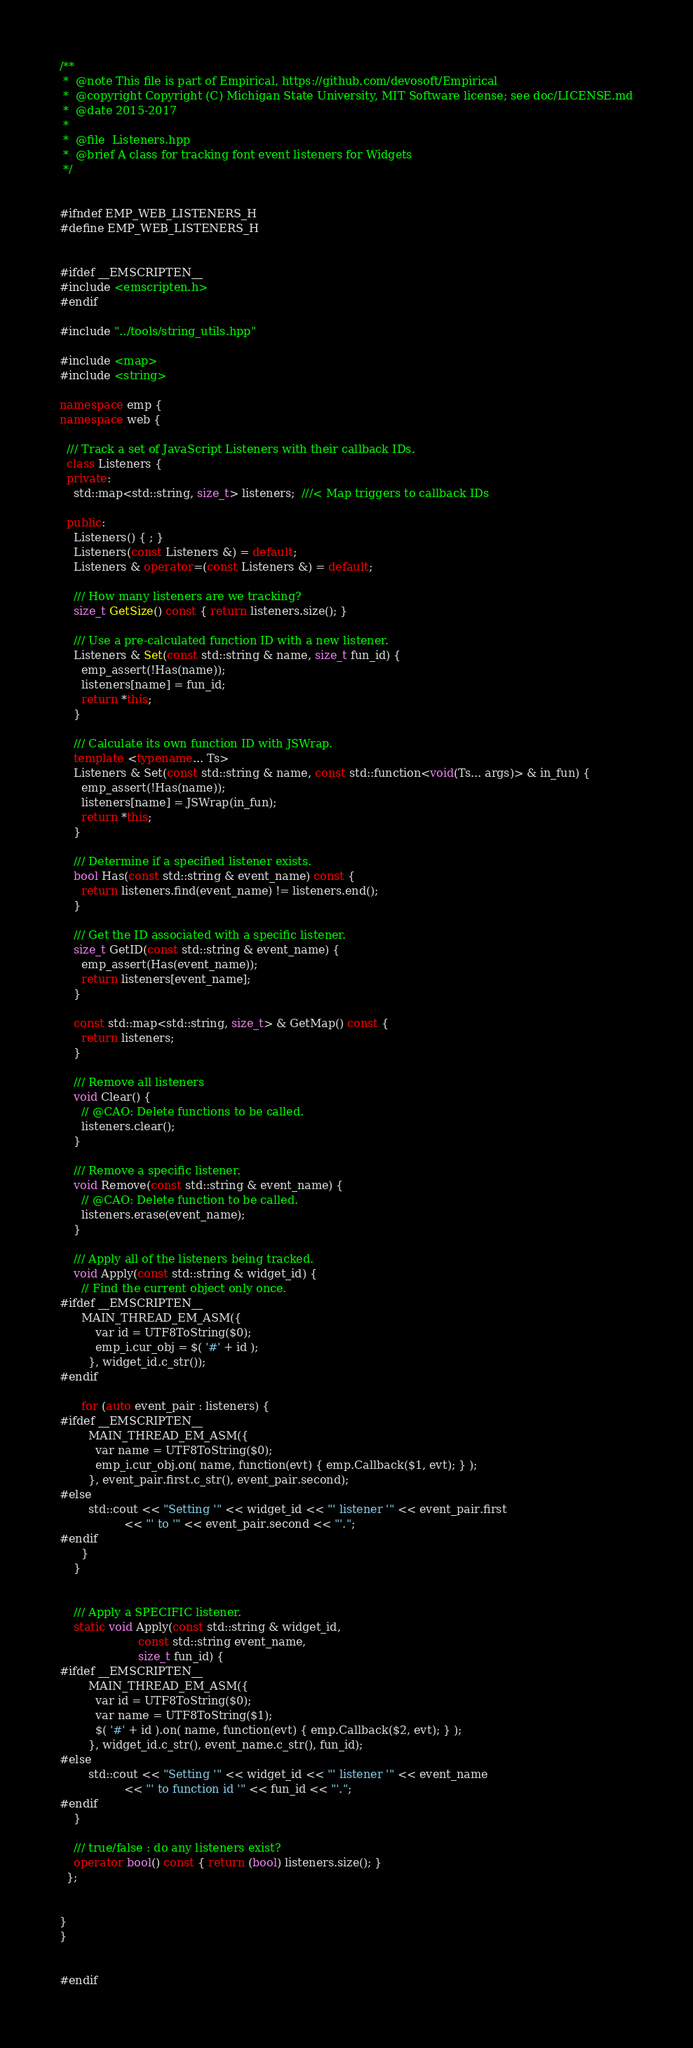Convert code to text. <code><loc_0><loc_0><loc_500><loc_500><_C++_>/**
 *  @note This file is part of Empirical, https://github.com/devosoft/Empirical
 *  @copyright Copyright (C) Michigan State University, MIT Software license; see doc/LICENSE.md
 *  @date 2015-2017
 *
 *  @file  Listeners.hpp
 *  @brief A class for tracking font event listeners for Widgets
 */


#ifndef EMP_WEB_LISTENERS_H
#define EMP_WEB_LISTENERS_H


#ifdef __EMSCRIPTEN__
#include <emscripten.h>
#endif

#include "../tools/string_utils.hpp"

#include <map>
#include <string>

namespace emp {
namespace web {

  /// Track a set of JavaScript Listeners with their callback IDs.
  class Listeners {
  private:
    std::map<std::string, size_t> listeners;  ///< Map triggers to callback IDs

  public:
    Listeners() { ; }
    Listeners(const Listeners &) = default;
    Listeners & operator=(const Listeners &) = default;

    /// How many listeners are we tracking?
    size_t GetSize() const { return listeners.size(); }

    /// Use a pre-calculated function ID with a new listener.
    Listeners & Set(const std::string & name, size_t fun_id) {
      emp_assert(!Has(name));
      listeners[name] = fun_id;
      return *this;
    }

    /// Calculate its own function ID with JSWrap.
    template <typename... Ts>
    Listeners & Set(const std::string & name, const std::function<void(Ts... args)> & in_fun) {
      emp_assert(!Has(name));
      listeners[name] = JSWrap(in_fun);
      return *this;
    }

    /// Determine if a specified listener exists.
    bool Has(const std::string & event_name) const {
      return listeners.find(event_name) != listeners.end();
    }

    /// Get the ID associated with a specific listener.
    size_t GetID(const std::string & event_name) {
      emp_assert(Has(event_name));
      return listeners[event_name];
    }

    const std::map<std::string, size_t> & GetMap() const {
      return listeners;
    }

    /// Remove all listeners
    void Clear() {
      // @CAO: Delete functions to be called.
      listeners.clear();
    }

    /// Remove a specific listener.
    void Remove(const std::string & event_name) {
      // @CAO: Delete function to be called.
      listeners.erase(event_name);
    }

    /// Apply all of the listeners being tracked.
    void Apply(const std::string & widget_id) {
      // Find the current object only once.
#ifdef __EMSCRIPTEN__
      MAIN_THREAD_EM_ASM({
          var id = UTF8ToString($0);
          emp_i.cur_obj = $( '#' + id );
        }, widget_id.c_str());
#endif

      for (auto event_pair : listeners) {
#ifdef __EMSCRIPTEN__
        MAIN_THREAD_EM_ASM({
          var name = UTF8ToString($0);
          emp_i.cur_obj.on( name, function(evt) { emp.Callback($1, evt); } );
        }, event_pair.first.c_str(), event_pair.second);
#else
        std::cout << "Setting '" << widget_id << "' listener '" << event_pair.first
                  << "' to '" << event_pair.second << "'.";
#endif
      }
    }


    /// Apply a SPECIFIC listener.
    static void Apply(const std::string & widget_id,
                      const std::string event_name,
                      size_t fun_id) {
#ifdef __EMSCRIPTEN__
        MAIN_THREAD_EM_ASM({
          var id = UTF8ToString($0);
          var name = UTF8ToString($1);
          $( '#' + id ).on( name, function(evt) { emp.Callback($2, evt); } );
        }, widget_id.c_str(), event_name.c_str(), fun_id);
#else
        std::cout << "Setting '" << widget_id << "' listener '" << event_name
                  << "' to function id '" << fun_id << "'.";
#endif
    }

    /// true/false : do any listeners exist?
    operator bool() const { return (bool) listeners.size(); }
  };


}
}


#endif
</code> 